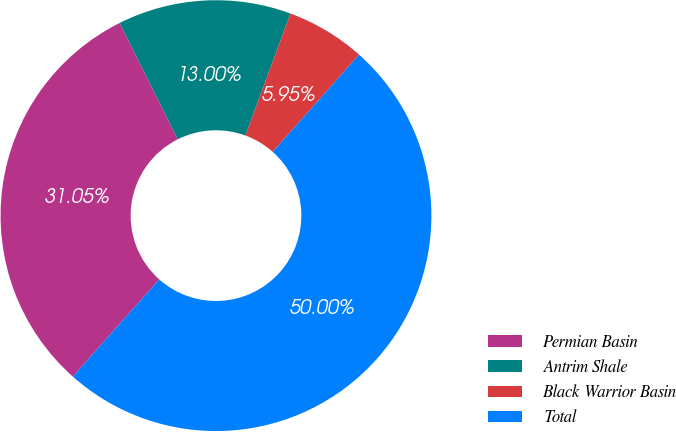Convert chart to OTSL. <chart><loc_0><loc_0><loc_500><loc_500><pie_chart><fcel>Permian Basin<fcel>Antrim Shale<fcel>Black Warrior Basin<fcel>Total<nl><fcel>31.05%<fcel>13.0%<fcel>5.95%<fcel>50.0%<nl></chart> 